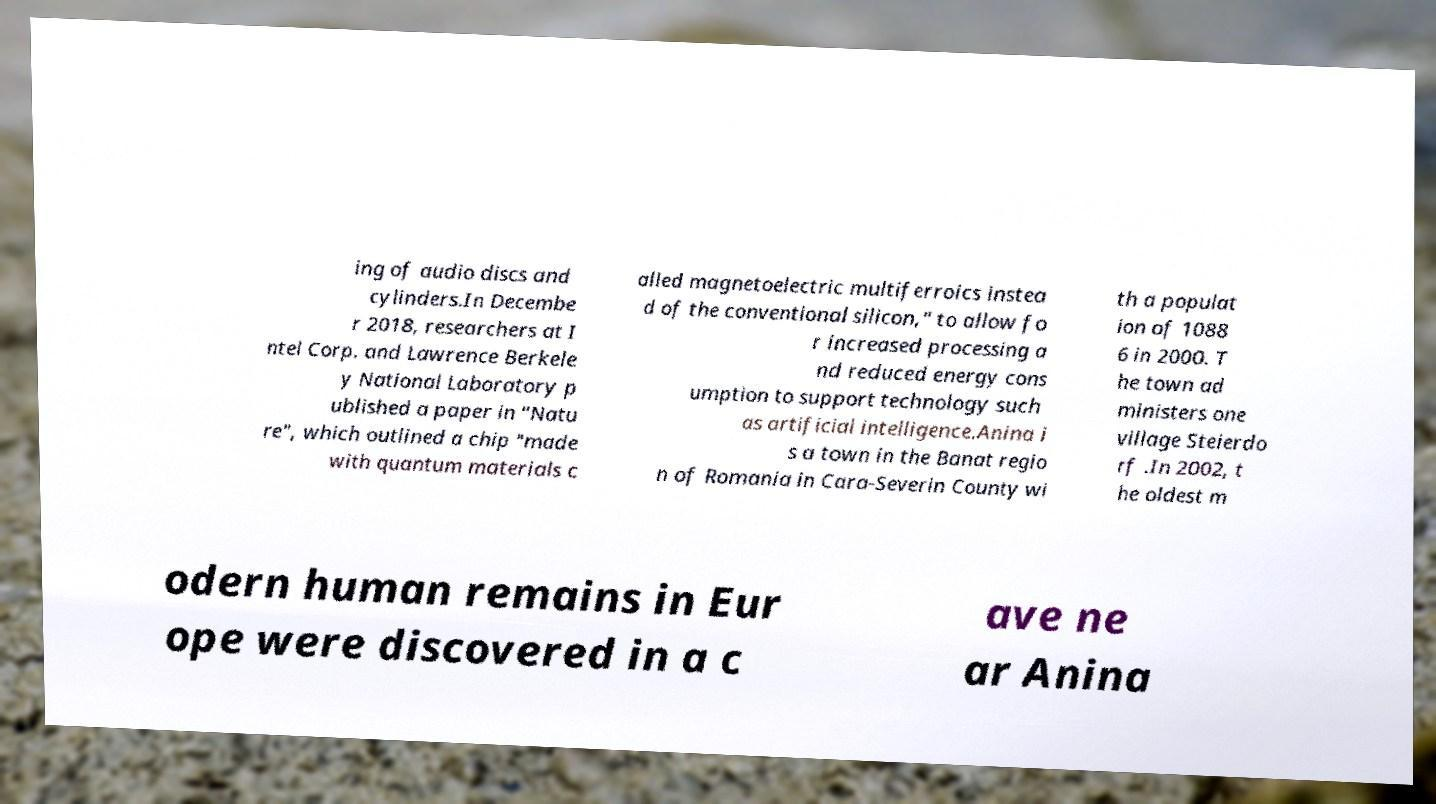There's text embedded in this image that I need extracted. Can you transcribe it verbatim? ing of audio discs and cylinders.In Decembe r 2018, researchers at I ntel Corp. and Lawrence Berkele y National Laboratory p ublished a paper in "Natu re", which outlined a chip "made with quantum materials c alled magnetoelectric multiferroics instea d of the conventional silicon," to allow fo r increased processing a nd reduced energy cons umption to support technology such as artificial intelligence.Anina i s a town in the Banat regio n of Romania in Cara-Severin County wi th a populat ion of 1088 6 in 2000. T he town ad ministers one village Steierdo rf .In 2002, t he oldest m odern human remains in Eur ope were discovered in a c ave ne ar Anina 